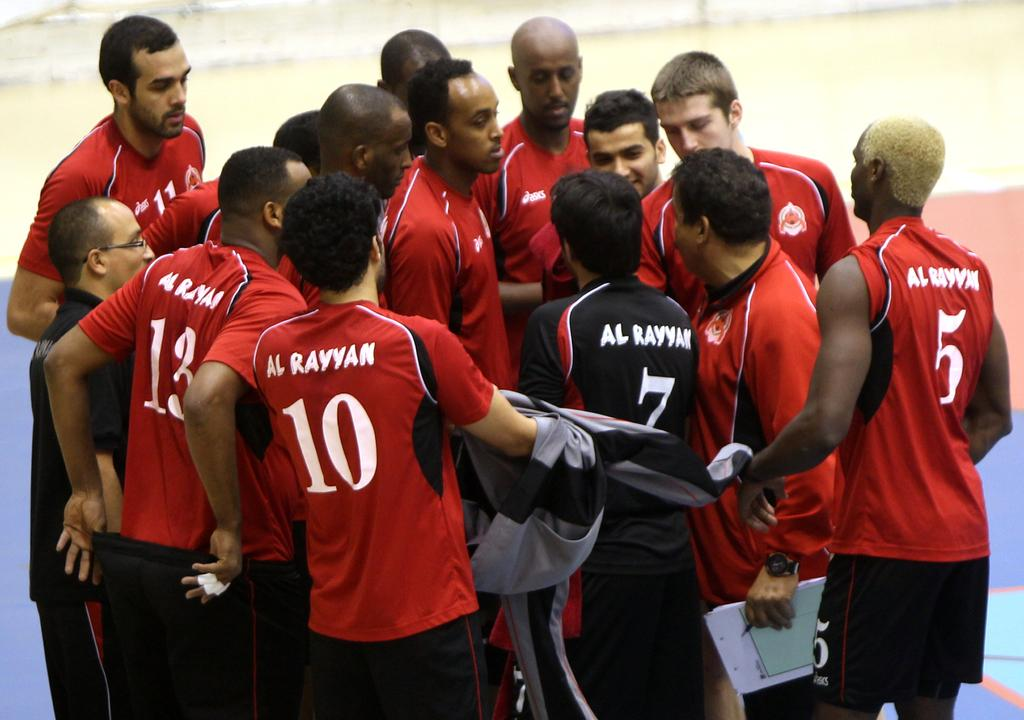Provide a one-sentence caption for the provided image. Player number 13, 10 and 5 are on the outside of the huddle. 